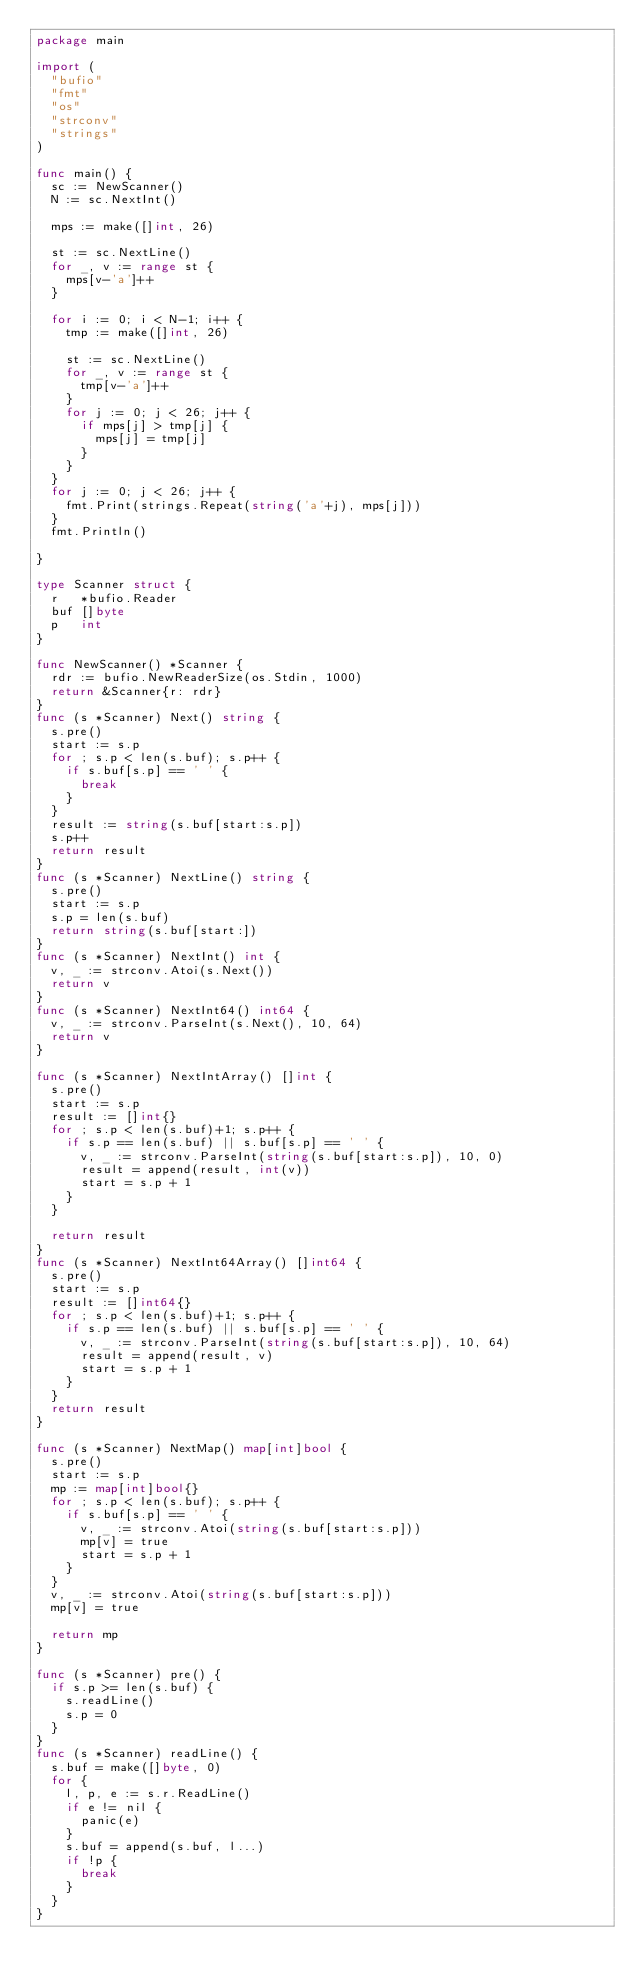<code> <loc_0><loc_0><loc_500><loc_500><_Go_>package main

import (
	"bufio"
	"fmt"
	"os"
	"strconv"
	"strings"
)

func main() {
	sc := NewScanner()
	N := sc.NextInt()

	mps := make([]int, 26)

	st := sc.NextLine()
	for _, v := range st {
		mps[v-'a']++
	}

	for i := 0; i < N-1; i++ {
		tmp := make([]int, 26)

		st := sc.NextLine()
		for _, v := range st {
			tmp[v-'a']++
		}
		for j := 0; j < 26; j++ {
			if mps[j] > tmp[j] {
				mps[j] = tmp[j]
			}
		}
	}
	for j := 0; j < 26; j++ {
		fmt.Print(strings.Repeat(string('a'+j), mps[j]))
	}
	fmt.Println()

}

type Scanner struct {
	r   *bufio.Reader
	buf []byte
	p   int
}

func NewScanner() *Scanner {
	rdr := bufio.NewReaderSize(os.Stdin, 1000)
	return &Scanner{r: rdr}
}
func (s *Scanner) Next() string {
	s.pre()
	start := s.p
	for ; s.p < len(s.buf); s.p++ {
		if s.buf[s.p] == ' ' {
			break
		}
	}
	result := string(s.buf[start:s.p])
	s.p++
	return result
}
func (s *Scanner) NextLine() string {
	s.pre()
	start := s.p
	s.p = len(s.buf)
	return string(s.buf[start:])
}
func (s *Scanner) NextInt() int {
	v, _ := strconv.Atoi(s.Next())
	return v
}
func (s *Scanner) NextInt64() int64 {
	v, _ := strconv.ParseInt(s.Next(), 10, 64)
	return v
}

func (s *Scanner) NextIntArray() []int {
	s.pre()
	start := s.p
	result := []int{}
	for ; s.p < len(s.buf)+1; s.p++ {
		if s.p == len(s.buf) || s.buf[s.p] == ' ' {
			v, _ := strconv.ParseInt(string(s.buf[start:s.p]), 10, 0)
			result = append(result, int(v))
			start = s.p + 1
		}
	}

	return result
}
func (s *Scanner) NextInt64Array() []int64 {
	s.pre()
	start := s.p
	result := []int64{}
	for ; s.p < len(s.buf)+1; s.p++ {
		if s.p == len(s.buf) || s.buf[s.p] == ' ' {
			v, _ := strconv.ParseInt(string(s.buf[start:s.p]), 10, 64)
			result = append(result, v)
			start = s.p + 1
		}
	}
	return result
}

func (s *Scanner) NextMap() map[int]bool {
	s.pre()
	start := s.p
	mp := map[int]bool{}
	for ; s.p < len(s.buf); s.p++ {
		if s.buf[s.p] == ' ' {
			v, _ := strconv.Atoi(string(s.buf[start:s.p]))
			mp[v] = true
			start = s.p + 1
		}
	}
	v, _ := strconv.Atoi(string(s.buf[start:s.p]))
	mp[v] = true

	return mp
}

func (s *Scanner) pre() {
	if s.p >= len(s.buf) {
		s.readLine()
		s.p = 0
	}
}
func (s *Scanner) readLine() {
	s.buf = make([]byte, 0)
	for {
		l, p, e := s.r.ReadLine()
		if e != nil {
			panic(e)
		}
		s.buf = append(s.buf, l...)
		if !p {
			break
		}
	}
}
</code> 